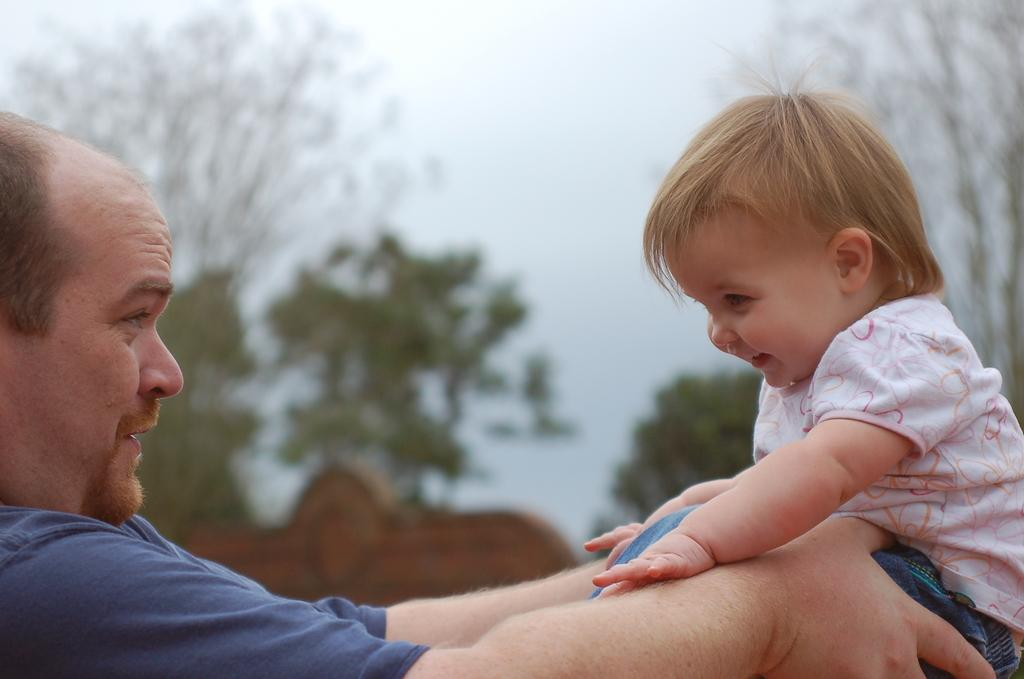What is the person in the image wearing? The person is wearing a blue t-shirt in the image. What is the facial expression of the person in the image? The person is smiling in the image. Who else is present in the image? There is a child in the image. What is the facial expression of the child in the image? The child is smiling in the image. How would you describe the background of the image? The background of the image is slightly blurred, with trees and the sky visible. What sign is the person holding in the image? There is no sign present in the image; the person is simply wearing a blue t-shirt and smiling. 